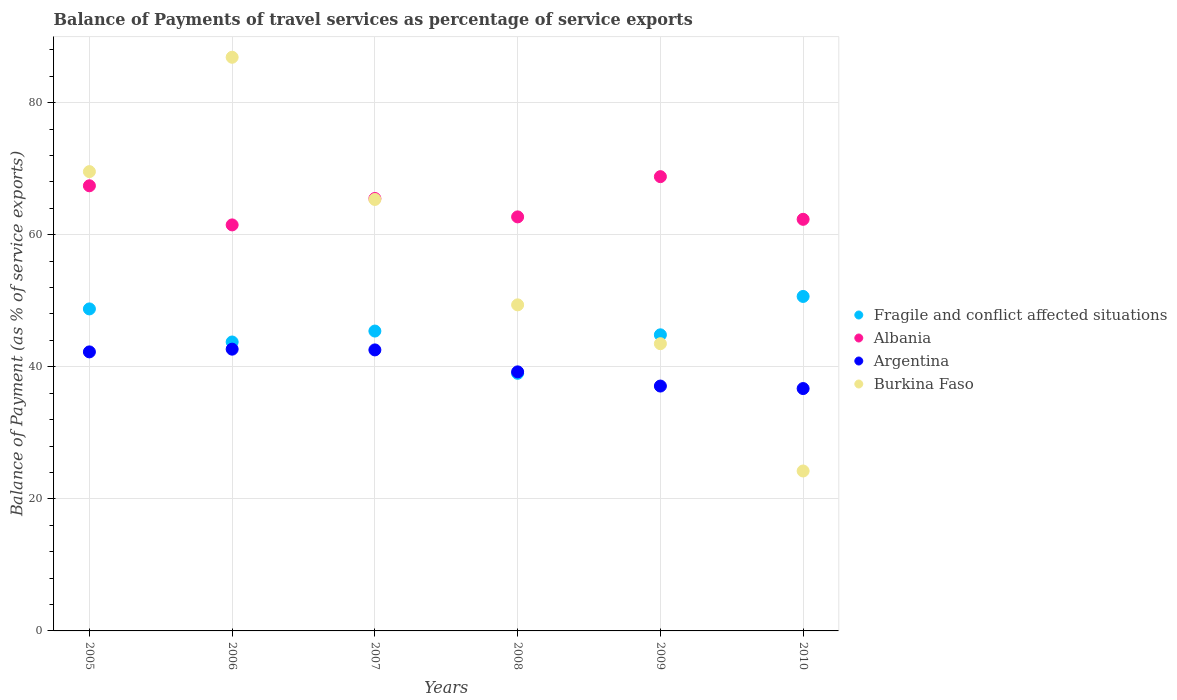How many different coloured dotlines are there?
Offer a very short reply. 4. Is the number of dotlines equal to the number of legend labels?
Your answer should be very brief. Yes. What is the balance of payments of travel services in Fragile and conflict affected situations in 2008?
Give a very brief answer. 39.02. Across all years, what is the maximum balance of payments of travel services in Fragile and conflict affected situations?
Keep it short and to the point. 50.66. Across all years, what is the minimum balance of payments of travel services in Burkina Faso?
Make the answer very short. 24.22. In which year was the balance of payments of travel services in Fragile and conflict affected situations maximum?
Your response must be concise. 2010. In which year was the balance of payments of travel services in Burkina Faso minimum?
Provide a succinct answer. 2010. What is the total balance of payments of travel services in Argentina in the graph?
Offer a very short reply. 240.51. What is the difference between the balance of payments of travel services in Burkina Faso in 2005 and that in 2008?
Offer a terse response. 20.18. What is the difference between the balance of payments of travel services in Argentina in 2005 and the balance of payments of travel services in Albania in 2010?
Offer a very short reply. -20.08. What is the average balance of payments of travel services in Fragile and conflict affected situations per year?
Give a very brief answer. 45.41. In the year 2007, what is the difference between the balance of payments of travel services in Albania and balance of payments of travel services in Fragile and conflict affected situations?
Your answer should be compact. 20.08. In how many years, is the balance of payments of travel services in Albania greater than 8 %?
Provide a succinct answer. 6. What is the ratio of the balance of payments of travel services in Fragile and conflict affected situations in 2007 to that in 2009?
Provide a succinct answer. 1.01. Is the balance of payments of travel services in Burkina Faso in 2007 less than that in 2008?
Give a very brief answer. No. Is the difference between the balance of payments of travel services in Albania in 2009 and 2010 greater than the difference between the balance of payments of travel services in Fragile and conflict affected situations in 2009 and 2010?
Offer a terse response. Yes. What is the difference between the highest and the second highest balance of payments of travel services in Fragile and conflict affected situations?
Provide a succinct answer. 1.89. What is the difference between the highest and the lowest balance of payments of travel services in Fragile and conflict affected situations?
Keep it short and to the point. 11.64. Is it the case that in every year, the sum of the balance of payments of travel services in Argentina and balance of payments of travel services in Burkina Faso  is greater than the sum of balance of payments of travel services in Fragile and conflict affected situations and balance of payments of travel services in Albania?
Provide a succinct answer. No. Does the balance of payments of travel services in Argentina monotonically increase over the years?
Your answer should be very brief. No. How many dotlines are there?
Make the answer very short. 4. Does the graph contain grids?
Offer a terse response. Yes. How many legend labels are there?
Give a very brief answer. 4. What is the title of the graph?
Keep it short and to the point. Balance of Payments of travel services as percentage of service exports. What is the label or title of the X-axis?
Give a very brief answer. Years. What is the label or title of the Y-axis?
Your answer should be very brief. Balance of Payment (as % of service exports). What is the Balance of Payment (as % of service exports) of Fragile and conflict affected situations in 2005?
Provide a succinct answer. 48.77. What is the Balance of Payment (as % of service exports) of Albania in 2005?
Offer a very short reply. 67.42. What is the Balance of Payment (as % of service exports) in Argentina in 2005?
Ensure brevity in your answer.  42.26. What is the Balance of Payment (as % of service exports) in Burkina Faso in 2005?
Your response must be concise. 69.56. What is the Balance of Payment (as % of service exports) of Fragile and conflict affected situations in 2006?
Offer a very short reply. 43.76. What is the Balance of Payment (as % of service exports) of Albania in 2006?
Provide a short and direct response. 61.49. What is the Balance of Payment (as % of service exports) in Argentina in 2006?
Make the answer very short. 42.67. What is the Balance of Payment (as % of service exports) of Burkina Faso in 2006?
Provide a succinct answer. 86.88. What is the Balance of Payment (as % of service exports) of Fragile and conflict affected situations in 2007?
Your answer should be very brief. 45.41. What is the Balance of Payment (as % of service exports) of Albania in 2007?
Offer a very short reply. 65.49. What is the Balance of Payment (as % of service exports) of Argentina in 2007?
Ensure brevity in your answer.  42.56. What is the Balance of Payment (as % of service exports) of Burkina Faso in 2007?
Your answer should be compact. 65.35. What is the Balance of Payment (as % of service exports) in Fragile and conflict affected situations in 2008?
Your response must be concise. 39.02. What is the Balance of Payment (as % of service exports) in Albania in 2008?
Make the answer very short. 62.7. What is the Balance of Payment (as % of service exports) in Argentina in 2008?
Offer a terse response. 39.23. What is the Balance of Payment (as % of service exports) of Burkina Faso in 2008?
Your answer should be compact. 49.38. What is the Balance of Payment (as % of service exports) of Fragile and conflict affected situations in 2009?
Keep it short and to the point. 44.84. What is the Balance of Payment (as % of service exports) of Albania in 2009?
Provide a succinct answer. 68.8. What is the Balance of Payment (as % of service exports) of Argentina in 2009?
Ensure brevity in your answer.  37.08. What is the Balance of Payment (as % of service exports) in Burkina Faso in 2009?
Provide a succinct answer. 43.5. What is the Balance of Payment (as % of service exports) in Fragile and conflict affected situations in 2010?
Your response must be concise. 50.66. What is the Balance of Payment (as % of service exports) of Albania in 2010?
Give a very brief answer. 62.34. What is the Balance of Payment (as % of service exports) in Argentina in 2010?
Ensure brevity in your answer.  36.71. What is the Balance of Payment (as % of service exports) of Burkina Faso in 2010?
Keep it short and to the point. 24.22. Across all years, what is the maximum Balance of Payment (as % of service exports) in Fragile and conflict affected situations?
Give a very brief answer. 50.66. Across all years, what is the maximum Balance of Payment (as % of service exports) in Albania?
Give a very brief answer. 68.8. Across all years, what is the maximum Balance of Payment (as % of service exports) in Argentina?
Your answer should be compact. 42.67. Across all years, what is the maximum Balance of Payment (as % of service exports) of Burkina Faso?
Your response must be concise. 86.88. Across all years, what is the minimum Balance of Payment (as % of service exports) in Fragile and conflict affected situations?
Your response must be concise. 39.02. Across all years, what is the minimum Balance of Payment (as % of service exports) of Albania?
Provide a short and direct response. 61.49. Across all years, what is the minimum Balance of Payment (as % of service exports) of Argentina?
Offer a terse response. 36.71. Across all years, what is the minimum Balance of Payment (as % of service exports) in Burkina Faso?
Offer a very short reply. 24.22. What is the total Balance of Payment (as % of service exports) in Fragile and conflict affected situations in the graph?
Provide a short and direct response. 272.46. What is the total Balance of Payment (as % of service exports) of Albania in the graph?
Your answer should be compact. 388.24. What is the total Balance of Payment (as % of service exports) in Argentina in the graph?
Give a very brief answer. 240.51. What is the total Balance of Payment (as % of service exports) in Burkina Faso in the graph?
Ensure brevity in your answer.  338.89. What is the difference between the Balance of Payment (as % of service exports) of Fragile and conflict affected situations in 2005 and that in 2006?
Your response must be concise. 5.01. What is the difference between the Balance of Payment (as % of service exports) in Albania in 2005 and that in 2006?
Your response must be concise. 5.92. What is the difference between the Balance of Payment (as % of service exports) in Argentina in 2005 and that in 2006?
Ensure brevity in your answer.  -0.41. What is the difference between the Balance of Payment (as % of service exports) of Burkina Faso in 2005 and that in 2006?
Provide a short and direct response. -17.32. What is the difference between the Balance of Payment (as % of service exports) of Fragile and conflict affected situations in 2005 and that in 2007?
Provide a succinct answer. 3.35. What is the difference between the Balance of Payment (as % of service exports) in Albania in 2005 and that in 2007?
Provide a succinct answer. 1.92. What is the difference between the Balance of Payment (as % of service exports) of Argentina in 2005 and that in 2007?
Your answer should be compact. -0.3. What is the difference between the Balance of Payment (as % of service exports) in Burkina Faso in 2005 and that in 2007?
Ensure brevity in your answer.  4.22. What is the difference between the Balance of Payment (as % of service exports) of Fragile and conflict affected situations in 2005 and that in 2008?
Your response must be concise. 9.75. What is the difference between the Balance of Payment (as % of service exports) in Albania in 2005 and that in 2008?
Provide a short and direct response. 4.71. What is the difference between the Balance of Payment (as % of service exports) of Argentina in 2005 and that in 2008?
Provide a succinct answer. 3.02. What is the difference between the Balance of Payment (as % of service exports) in Burkina Faso in 2005 and that in 2008?
Provide a succinct answer. 20.18. What is the difference between the Balance of Payment (as % of service exports) in Fragile and conflict affected situations in 2005 and that in 2009?
Provide a short and direct response. 3.92. What is the difference between the Balance of Payment (as % of service exports) in Albania in 2005 and that in 2009?
Provide a short and direct response. -1.38. What is the difference between the Balance of Payment (as % of service exports) in Argentina in 2005 and that in 2009?
Provide a short and direct response. 5.17. What is the difference between the Balance of Payment (as % of service exports) of Burkina Faso in 2005 and that in 2009?
Give a very brief answer. 26.06. What is the difference between the Balance of Payment (as % of service exports) in Fragile and conflict affected situations in 2005 and that in 2010?
Make the answer very short. -1.89. What is the difference between the Balance of Payment (as % of service exports) in Albania in 2005 and that in 2010?
Keep it short and to the point. 5.08. What is the difference between the Balance of Payment (as % of service exports) of Argentina in 2005 and that in 2010?
Provide a succinct answer. 5.55. What is the difference between the Balance of Payment (as % of service exports) of Burkina Faso in 2005 and that in 2010?
Ensure brevity in your answer.  45.34. What is the difference between the Balance of Payment (as % of service exports) of Fragile and conflict affected situations in 2006 and that in 2007?
Give a very brief answer. -1.66. What is the difference between the Balance of Payment (as % of service exports) in Albania in 2006 and that in 2007?
Ensure brevity in your answer.  -4. What is the difference between the Balance of Payment (as % of service exports) in Argentina in 2006 and that in 2007?
Offer a very short reply. 0.11. What is the difference between the Balance of Payment (as % of service exports) of Burkina Faso in 2006 and that in 2007?
Offer a terse response. 21.53. What is the difference between the Balance of Payment (as % of service exports) of Fragile and conflict affected situations in 2006 and that in 2008?
Make the answer very short. 4.74. What is the difference between the Balance of Payment (as % of service exports) of Albania in 2006 and that in 2008?
Give a very brief answer. -1.21. What is the difference between the Balance of Payment (as % of service exports) in Argentina in 2006 and that in 2008?
Provide a short and direct response. 3.44. What is the difference between the Balance of Payment (as % of service exports) in Burkina Faso in 2006 and that in 2008?
Your answer should be compact. 37.5. What is the difference between the Balance of Payment (as % of service exports) of Fragile and conflict affected situations in 2006 and that in 2009?
Your answer should be very brief. -1.09. What is the difference between the Balance of Payment (as % of service exports) of Albania in 2006 and that in 2009?
Make the answer very short. -7.31. What is the difference between the Balance of Payment (as % of service exports) in Argentina in 2006 and that in 2009?
Ensure brevity in your answer.  5.59. What is the difference between the Balance of Payment (as % of service exports) of Burkina Faso in 2006 and that in 2009?
Make the answer very short. 43.38. What is the difference between the Balance of Payment (as % of service exports) of Fragile and conflict affected situations in 2006 and that in 2010?
Offer a very short reply. -6.9. What is the difference between the Balance of Payment (as % of service exports) of Albania in 2006 and that in 2010?
Provide a short and direct response. -0.85. What is the difference between the Balance of Payment (as % of service exports) of Argentina in 2006 and that in 2010?
Offer a terse response. 5.97. What is the difference between the Balance of Payment (as % of service exports) of Burkina Faso in 2006 and that in 2010?
Provide a short and direct response. 62.66. What is the difference between the Balance of Payment (as % of service exports) of Fragile and conflict affected situations in 2007 and that in 2008?
Make the answer very short. 6.4. What is the difference between the Balance of Payment (as % of service exports) in Albania in 2007 and that in 2008?
Provide a short and direct response. 2.79. What is the difference between the Balance of Payment (as % of service exports) of Argentina in 2007 and that in 2008?
Your response must be concise. 3.32. What is the difference between the Balance of Payment (as % of service exports) of Burkina Faso in 2007 and that in 2008?
Give a very brief answer. 15.96. What is the difference between the Balance of Payment (as % of service exports) of Fragile and conflict affected situations in 2007 and that in 2009?
Your answer should be compact. 0.57. What is the difference between the Balance of Payment (as % of service exports) in Albania in 2007 and that in 2009?
Provide a succinct answer. -3.31. What is the difference between the Balance of Payment (as % of service exports) in Argentina in 2007 and that in 2009?
Offer a very short reply. 5.47. What is the difference between the Balance of Payment (as % of service exports) of Burkina Faso in 2007 and that in 2009?
Give a very brief answer. 21.85. What is the difference between the Balance of Payment (as % of service exports) in Fragile and conflict affected situations in 2007 and that in 2010?
Your answer should be compact. -5.24. What is the difference between the Balance of Payment (as % of service exports) in Albania in 2007 and that in 2010?
Make the answer very short. 3.16. What is the difference between the Balance of Payment (as % of service exports) in Argentina in 2007 and that in 2010?
Your response must be concise. 5.85. What is the difference between the Balance of Payment (as % of service exports) in Burkina Faso in 2007 and that in 2010?
Keep it short and to the point. 41.12. What is the difference between the Balance of Payment (as % of service exports) of Fragile and conflict affected situations in 2008 and that in 2009?
Provide a short and direct response. -5.83. What is the difference between the Balance of Payment (as % of service exports) in Albania in 2008 and that in 2009?
Provide a succinct answer. -6.09. What is the difference between the Balance of Payment (as % of service exports) in Argentina in 2008 and that in 2009?
Your answer should be compact. 2.15. What is the difference between the Balance of Payment (as % of service exports) in Burkina Faso in 2008 and that in 2009?
Make the answer very short. 5.88. What is the difference between the Balance of Payment (as % of service exports) of Fragile and conflict affected situations in 2008 and that in 2010?
Give a very brief answer. -11.64. What is the difference between the Balance of Payment (as % of service exports) of Albania in 2008 and that in 2010?
Ensure brevity in your answer.  0.37. What is the difference between the Balance of Payment (as % of service exports) of Argentina in 2008 and that in 2010?
Give a very brief answer. 2.53. What is the difference between the Balance of Payment (as % of service exports) in Burkina Faso in 2008 and that in 2010?
Ensure brevity in your answer.  25.16. What is the difference between the Balance of Payment (as % of service exports) of Fragile and conflict affected situations in 2009 and that in 2010?
Give a very brief answer. -5.81. What is the difference between the Balance of Payment (as % of service exports) in Albania in 2009 and that in 2010?
Give a very brief answer. 6.46. What is the difference between the Balance of Payment (as % of service exports) in Argentina in 2009 and that in 2010?
Ensure brevity in your answer.  0.38. What is the difference between the Balance of Payment (as % of service exports) in Burkina Faso in 2009 and that in 2010?
Provide a succinct answer. 19.28. What is the difference between the Balance of Payment (as % of service exports) in Fragile and conflict affected situations in 2005 and the Balance of Payment (as % of service exports) in Albania in 2006?
Your answer should be compact. -12.72. What is the difference between the Balance of Payment (as % of service exports) of Fragile and conflict affected situations in 2005 and the Balance of Payment (as % of service exports) of Argentina in 2006?
Ensure brevity in your answer.  6.1. What is the difference between the Balance of Payment (as % of service exports) of Fragile and conflict affected situations in 2005 and the Balance of Payment (as % of service exports) of Burkina Faso in 2006?
Your answer should be very brief. -38.11. What is the difference between the Balance of Payment (as % of service exports) in Albania in 2005 and the Balance of Payment (as % of service exports) in Argentina in 2006?
Keep it short and to the point. 24.74. What is the difference between the Balance of Payment (as % of service exports) of Albania in 2005 and the Balance of Payment (as % of service exports) of Burkina Faso in 2006?
Your response must be concise. -19.46. What is the difference between the Balance of Payment (as % of service exports) in Argentina in 2005 and the Balance of Payment (as % of service exports) in Burkina Faso in 2006?
Make the answer very short. -44.62. What is the difference between the Balance of Payment (as % of service exports) of Fragile and conflict affected situations in 2005 and the Balance of Payment (as % of service exports) of Albania in 2007?
Your answer should be very brief. -16.72. What is the difference between the Balance of Payment (as % of service exports) in Fragile and conflict affected situations in 2005 and the Balance of Payment (as % of service exports) in Argentina in 2007?
Provide a succinct answer. 6.21. What is the difference between the Balance of Payment (as % of service exports) in Fragile and conflict affected situations in 2005 and the Balance of Payment (as % of service exports) in Burkina Faso in 2007?
Your answer should be compact. -16.58. What is the difference between the Balance of Payment (as % of service exports) of Albania in 2005 and the Balance of Payment (as % of service exports) of Argentina in 2007?
Ensure brevity in your answer.  24.86. What is the difference between the Balance of Payment (as % of service exports) in Albania in 2005 and the Balance of Payment (as % of service exports) in Burkina Faso in 2007?
Your response must be concise. 2.07. What is the difference between the Balance of Payment (as % of service exports) of Argentina in 2005 and the Balance of Payment (as % of service exports) of Burkina Faso in 2007?
Your answer should be very brief. -23.09. What is the difference between the Balance of Payment (as % of service exports) of Fragile and conflict affected situations in 2005 and the Balance of Payment (as % of service exports) of Albania in 2008?
Make the answer very short. -13.94. What is the difference between the Balance of Payment (as % of service exports) in Fragile and conflict affected situations in 2005 and the Balance of Payment (as % of service exports) in Argentina in 2008?
Make the answer very short. 9.53. What is the difference between the Balance of Payment (as % of service exports) of Fragile and conflict affected situations in 2005 and the Balance of Payment (as % of service exports) of Burkina Faso in 2008?
Your answer should be compact. -0.61. What is the difference between the Balance of Payment (as % of service exports) of Albania in 2005 and the Balance of Payment (as % of service exports) of Argentina in 2008?
Make the answer very short. 28.18. What is the difference between the Balance of Payment (as % of service exports) in Albania in 2005 and the Balance of Payment (as % of service exports) in Burkina Faso in 2008?
Your response must be concise. 18.03. What is the difference between the Balance of Payment (as % of service exports) in Argentina in 2005 and the Balance of Payment (as % of service exports) in Burkina Faso in 2008?
Your answer should be compact. -7.12. What is the difference between the Balance of Payment (as % of service exports) in Fragile and conflict affected situations in 2005 and the Balance of Payment (as % of service exports) in Albania in 2009?
Make the answer very short. -20.03. What is the difference between the Balance of Payment (as % of service exports) of Fragile and conflict affected situations in 2005 and the Balance of Payment (as % of service exports) of Argentina in 2009?
Provide a short and direct response. 11.68. What is the difference between the Balance of Payment (as % of service exports) of Fragile and conflict affected situations in 2005 and the Balance of Payment (as % of service exports) of Burkina Faso in 2009?
Your answer should be very brief. 5.27. What is the difference between the Balance of Payment (as % of service exports) in Albania in 2005 and the Balance of Payment (as % of service exports) in Argentina in 2009?
Ensure brevity in your answer.  30.33. What is the difference between the Balance of Payment (as % of service exports) of Albania in 2005 and the Balance of Payment (as % of service exports) of Burkina Faso in 2009?
Keep it short and to the point. 23.92. What is the difference between the Balance of Payment (as % of service exports) in Argentina in 2005 and the Balance of Payment (as % of service exports) in Burkina Faso in 2009?
Give a very brief answer. -1.24. What is the difference between the Balance of Payment (as % of service exports) in Fragile and conflict affected situations in 2005 and the Balance of Payment (as % of service exports) in Albania in 2010?
Your response must be concise. -13.57. What is the difference between the Balance of Payment (as % of service exports) of Fragile and conflict affected situations in 2005 and the Balance of Payment (as % of service exports) of Argentina in 2010?
Make the answer very short. 12.06. What is the difference between the Balance of Payment (as % of service exports) in Fragile and conflict affected situations in 2005 and the Balance of Payment (as % of service exports) in Burkina Faso in 2010?
Your response must be concise. 24.55. What is the difference between the Balance of Payment (as % of service exports) in Albania in 2005 and the Balance of Payment (as % of service exports) in Argentina in 2010?
Make the answer very short. 30.71. What is the difference between the Balance of Payment (as % of service exports) of Albania in 2005 and the Balance of Payment (as % of service exports) of Burkina Faso in 2010?
Provide a short and direct response. 43.19. What is the difference between the Balance of Payment (as % of service exports) in Argentina in 2005 and the Balance of Payment (as % of service exports) in Burkina Faso in 2010?
Your response must be concise. 18.04. What is the difference between the Balance of Payment (as % of service exports) in Fragile and conflict affected situations in 2006 and the Balance of Payment (as % of service exports) in Albania in 2007?
Give a very brief answer. -21.73. What is the difference between the Balance of Payment (as % of service exports) of Fragile and conflict affected situations in 2006 and the Balance of Payment (as % of service exports) of Argentina in 2007?
Your response must be concise. 1.2. What is the difference between the Balance of Payment (as % of service exports) of Fragile and conflict affected situations in 2006 and the Balance of Payment (as % of service exports) of Burkina Faso in 2007?
Offer a terse response. -21.59. What is the difference between the Balance of Payment (as % of service exports) in Albania in 2006 and the Balance of Payment (as % of service exports) in Argentina in 2007?
Offer a terse response. 18.93. What is the difference between the Balance of Payment (as % of service exports) of Albania in 2006 and the Balance of Payment (as % of service exports) of Burkina Faso in 2007?
Offer a very short reply. -3.85. What is the difference between the Balance of Payment (as % of service exports) of Argentina in 2006 and the Balance of Payment (as % of service exports) of Burkina Faso in 2007?
Provide a succinct answer. -22.67. What is the difference between the Balance of Payment (as % of service exports) in Fragile and conflict affected situations in 2006 and the Balance of Payment (as % of service exports) in Albania in 2008?
Ensure brevity in your answer.  -18.95. What is the difference between the Balance of Payment (as % of service exports) in Fragile and conflict affected situations in 2006 and the Balance of Payment (as % of service exports) in Argentina in 2008?
Give a very brief answer. 4.52. What is the difference between the Balance of Payment (as % of service exports) of Fragile and conflict affected situations in 2006 and the Balance of Payment (as % of service exports) of Burkina Faso in 2008?
Keep it short and to the point. -5.62. What is the difference between the Balance of Payment (as % of service exports) in Albania in 2006 and the Balance of Payment (as % of service exports) in Argentina in 2008?
Keep it short and to the point. 22.26. What is the difference between the Balance of Payment (as % of service exports) of Albania in 2006 and the Balance of Payment (as % of service exports) of Burkina Faso in 2008?
Ensure brevity in your answer.  12.11. What is the difference between the Balance of Payment (as % of service exports) in Argentina in 2006 and the Balance of Payment (as % of service exports) in Burkina Faso in 2008?
Keep it short and to the point. -6.71. What is the difference between the Balance of Payment (as % of service exports) of Fragile and conflict affected situations in 2006 and the Balance of Payment (as % of service exports) of Albania in 2009?
Your answer should be compact. -25.04. What is the difference between the Balance of Payment (as % of service exports) in Fragile and conflict affected situations in 2006 and the Balance of Payment (as % of service exports) in Argentina in 2009?
Offer a very short reply. 6.67. What is the difference between the Balance of Payment (as % of service exports) of Fragile and conflict affected situations in 2006 and the Balance of Payment (as % of service exports) of Burkina Faso in 2009?
Offer a very short reply. 0.26. What is the difference between the Balance of Payment (as % of service exports) of Albania in 2006 and the Balance of Payment (as % of service exports) of Argentina in 2009?
Provide a short and direct response. 24.41. What is the difference between the Balance of Payment (as % of service exports) in Albania in 2006 and the Balance of Payment (as % of service exports) in Burkina Faso in 2009?
Your answer should be compact. 17.99. What is the difference between the Balance of Payment (as % of service exports) of Argentina in 2006 and the Balance of Payment (as % of service exports) of Burkina Faso in 2009?
Give a very brief answer. -0.83. What is the difference between the Balance of Payment (as % of service exports) in Fragile and conflict affected situations in 2006 and the Balance of Payment (as % of service exports) in Albania in 2010?
Provide a succinct answer. -18.58. What is the difference between the Balance of Payment (as % of service exports) of Fragile and conflict affected situations in 2006 and the Balance of Payment (as % of service exports) of Argentina in 2010?
Offer a terse response. 7.05. What is the difference between the Balance of Payment (as % of service exports) in Fragile and conflict affected situations in 2006 and the Balance of Payment (as % of service exports) in Burkina Faso in 2010?
Your answer should be very brief. 19.54. What is the difference between the Balance of Payment (as % of service exports) of Albania in 2006 and the Balance of Payment (as % of service exports) of Argentina in 2010?
Offer a very short reply. 24.78. What is the difference between the Balance of Payment (as % of service exports) of Albania in 2006 and the Balance of Payment (as % of service exports) of Burkina Faso in 2010?
Your answer should be very brief. 37.27. What is the difference between the Balance of Payment (as % of service exports) of Argentina in 2006 and the Balance of Payment (as % of service exports) of Burkina Faso in 2010?
Make the answer very short. 18.45. What is the difference between the Balance of Payment (as % of service exports) of Fragile and conflict affected situations in 2007 and the Balance of Payment (as % of service exports) of Albania in 2008?
Provide a succinct answer. -17.29. What is the difference between the Balance of Payment (as % of service exports) of Fragile and conflict affected situations in 2007 and the Balance of Payment (as % of service exports) of Argentina in 2008?
Your response must be concise. 6.18. What is the difference between the Balance of Payment (as % of service exports) in Fragile and conflict affected situations in 2007 and the Balance of Payment (as % of service exports) in Burkina Faso in 2008?
Provide a short and direct response. -3.97. What is the difference between the Balance of Payment (as % of service exports) in Albania in 2007 and the Balance of Payment (as % of service exports) in Argentina in 2008?
Give a very brief answer. 26.26. What is the difference between the Balance of Payment (as % of service exports) of Albania in 2007 and the Balance of Payment (as % of service exports) of Burkina Faso in 2008?
Give a very brief answer. 16.11. What is the difference between the Balance of Payment (as % of service exports) in Argentina in 2007 and the Balance of Payment (as % of service exports) in Burkina Faso in 2008?
Give a very brief answer. -6.82. What is the difference between the Balance of Payment (as % of service exports) of Fragile and conflict affected situations in 2007 and the Balance of Payment (as % of service exports) of Albania in 2009?
Your answer should be compact. -23.38. What is the difference between the Balance of Payment (as % of service exports) in Fragile and conflict affected situations in 2007 and the Balance of Payment (as % of service exports) in Argentina in 2009?
Offer a very short reply. 8.33. What is the difference between the Balance of Payment (as % of service exports) in Fragile and conflict affected situations in 2007 and the Balance of Payment (as % of service exports) in Burkina Faso in 2009?
Keep it short and to the point. 1.91. What is the difference between the Balance of Payment (as % of service exports) of Albania in 2007 and the Balance of Payment (as % of service exports) of Argentina in 2009?
Provide a short and direct response. 28.41. What is the difference between the Balance of Payment (as % of service exports) in Albania in 2007 and the Balance of Payment (as % of service exports) in Burkina Faso in 2009?
Your answer should be compact. 21.99. What is the difference between the Balance of Payment (as % of service exports) in Argentina in 2007 and the Balance of Payment (as % of service exports) in Burkina Faso in 2009?
Your answer should be very brief. -0.94. What is the difference between the Balance of Payment (as % of service exports) in Fragile and conflict affected situations in 2007 and the Balance of Payment (as % of service exports) in Albania in 2010?
Ensure brevity in your answer.  -16.92. What is the difference between the Balance of Payment (as % of service exports) in Fragile and conflict affected situations in 2007 and the Balance of Payment (as % of service exports) in Argentina in 2010?
Your answer should be very brief. 8.71. What is the difference between the Balance of Payment (as % of service exports) of Fragile and conflict affected situations in 2007 and the Balance of Payment (as % of service exports) of Burkina Faso in 2010?
Your answer should be very brief. 21.19. What is the difference between the Balance of Payment (as % of service exports) of Albania in 2007 and the Balance of Payment (as % of service exports) of Argentina in 2010?
Your answer should be compact. 28.79. What is the difference between the Balance of Payment (as % of service exports) in Albania in 2007 and the Balance of Payment (as % of service exports) in Burkina Faso in 2010?
Offer a terse response. 41.27. What is the difference between the Balance of Payment (as % of service exports) of Argentina in 2007 and the Balance of Payment (as % of service exports) of Burkina Faso in 2010?
Your answer should be very brief. 18.34. What is the difference between the Balance of Payment (as % of service exports) in Fragile and conflict affected situations in 2008 and the Balance of Payment (as % of service exports) in Albania in 2009?
Your response must be concise. -29.78. What is the difference between the Balance of Payment (as % of service exports) of Fragile and conflict affected situations in 2008 and the Balance of Payment (as % of service exports) of Argentina in 2009?
Provide a succinct answer. 1.93. What is the difference between the Balance of Payment (as % of service exports) of Fragile and conflict affected situations in 2008 and the Balance of Payment (as % of service exports) of Burkina Faso in 2009?
Provide a succinct answer. -4.48. What is the difference between the Balance of Payment (as % of service exports) in Albania in 2008 and the Balance of Payment (as % of service exports) in Argentina in 2009?
Your answer should be very brief. 25.62. What is the difference between the Balance of Payment (as % of service exports) in Albania in 2008 and the Balance of Payment (as % of service exports) in Burkina Faso in 2009?
Your response must be concise. 19.21. What is the difference between the Balance of Payment (as % of service exports) of Argentina in 2008 and the Balance of Payment (as % of service exports) of Burkina Faso in 2009?
Offer a very short reply. -4.27. What is the difference between the Balance of Payment (as % of service exports) in Fragile and conflict affected situations in 2008 and the Balance of Payment (as % of service exports) in Albania in 2010?
Your answer should be compact. -23.32. What is the difference between the Balance of Payment (as % of service exports) of Fragile and conflict affected situations in 2008 and the Balance of Payment (as % of service exports) of Argentina in 2010?
Give a very brief answer. 2.31. What is the difference between the Balance of Payment (as % of service exports) of Fragile and conflict affected situations in 2008 and the Balance of Payment (as % of service exports) of Burkina Faso in 2010?
Keep it short and to the point. 14.79. What is the difference between the Balance of Payment (as % of service exports) in Albania in 2008 and the Balance of Payment (as % of service exports) in Argentina in 2010?
Give a very brief answer. 26. What is the difference between the Balance of Payment (as % of service exports) of Albania in 2008 and the Balance of Payment (as % of service exports) of Burkina Faso in 2010?
Keep it short and to the point. 38.48. What is the difference between the Balance of Payment (as % of service exports) of Argentina in 2008 and the Balance of Payment (as % of service exports) of Burkina Faso in 2010?
Offer a very short reply. 15.01. What is the difference between the Balance of Payment (as % of service exports) of Fragile and conflict affected situations in 2009 and the Balance of Payment (as % of service exports) of Albania in 2010?
Your answer should be compact. -17.49. What is the difference between the Balance of Payment (as % of service exports) of Fragile and conflict affected situations in 2009 and the Balance of Payment (as % of service exports) of Argentina in 2010?
Provide a succinct answer. 8.14. What is the difference between the Balance of Payment (as % of service exports) of Fragile and conflict affected situations in 2009 and the Balance of Payment (as % of service exports) of Burkina Faso in 2010?
Make the answer very short. 20.62. What is the difference between the Balance of Payment (as % of service exports) in Albania in 2009 and the Balance of Payment (as % of service exports) in Argentina in 2010?
Keep it short and to the point. 32.09. What is the difference between the Balance of Payment (as % of service exports) of Albania in 2009 and the Balance of Payment (as % of service exports) of Burkina Faso in 2010?
Give a very brief answer. 44.58. What is the difference between the Balance of Payment (as % of service exports) of Argentina in 2009 and the Balance of Payment (as % of service exports) of Burkina Faso in 2010?
Provide a short and direct response. 12.86. What is the average Balance of Payment (as % of service exports) in Fragile and conflict affected situations per year?
Your response must be concise. 45.41. What is the average Balance of Payment (as % of service exports) in Albania per year?
Give a very brief answer. 64.71. What is the average Balance of Payment (as % of service exports) in Argentina per year?
Provide a short and direct response. 40.09. What is the average Balance of Payment (as % of service exports) in Burkina Faso per year?
Your answer should be compact. 56.48. In the year 2005, what is the difference between the Balance of Payment (as % of service exports) of Fragile and conflict affected situations and Balance of Payment (as % of service exports) of Albania?
Give a very brief answer. -18.65. In the year 2005, what is the difference between the Balance of Payment (as % of service exports) in Fragile and conflict affected situations and Balance of Payment (as % of service exports) in Argentina?
Give a very brief answer. 6.51. In the year 2005, what is the difference between the Balance of Payment (as % of service exports) in Fragile and conflict affected situations and Balance of Payment (as % of service exports) in Burkina Faso?
Your response must be concise. -20.79. In the year 2005, what is the difference between the Balance of Payment (as % of service exports) in Albania and Balance of Payment (as % of service exports) in Argentina?
Offer a terse response. 25.16. In the year 2005, what is the difference between the Balance of Payment (as % of service exports) in Albania and Balance of Payment (as % of service exports) in Burkina Faso?
Your answer should be compact. -2.15. In the year 2005, what is the difference between the Balance of Payment (as % of service exports) of Argentina and Balance of Payment (as % of service exports) of Burkina Faso?
Keep it short and to the point. -27.3. In the year 2006, what is the difference between the Balance of Payment (as % of service exports) in Fragile and conflict affected situations and Balance of Payment (as % of service exports) in Albania?
Offer a very short reply. -17.73. In the year 2006, what is the difference between the Balance of Payment (as % of service exports) of Fragile and conflict affected situations and Balance of Payment (as % of service exports) of Argentina?
Provide a succinct answer. 1.09. In the year 2006, what is the difference between the Balance of Payment (as % of service exports) of Fragile and conflict affected situations and Balance of Payment (as % of service exports) of Burkina Faso?
Ensure brevity in your answer.  -43.12. In the year 2006, what is the difference between the Balance of Payment (as % of service exports) of Albania and Balance of Payment (as % of service exports) of Argentina?
Ensure brevity in your answer.  18.82. In the year 2006, what is the difference between the Balance of Payment (as % of service exports) of Albania and Balance of Payment (as % of service exports) of Burkina Faso?
Provide a short and direct response. -25.39. In the year 2006, what is the difference between the Balance of Payment (as % of service exports) in Argentina and Balance of Payment (as % of service exports) in Burkina Faso?
Ensure brevity in your answer.  -44.21. In the year 2007, what is the difference between the Balance of Payment (as % of service exports) of Fragile and conflict affected situations and Balance of Payment (as % of service exports) of Albania?
Give a very brief answer. -20.08. In the year 2007, what is the difference between the Balance of Payment (as % of service exports) in Fragile and conflict affected situations and Balance of Payment (as % of service exports) in Argentina?
Make the answer very short. 2.86. In the year 2007, what is the difference between the Balance of Payment (as % of service exports) in Fragile and conflict affected situations and Balance of Payment (as % of service exports) in Burkina Faso?
Give a very brief answer. -19.93. In the year 2007, what is the difference between the Balance of Payment (as % of service exports) of Albania and Balance of Payment (as % of service exports) of Argentina?
Your response must be concise. 22.93. In the year 2007, what is the difference between the Balance of Payment (as % of service exports) in Albania and Balance of Payment (as % of service exports) in Burkina Faso?
Provide a short and direct response. 0.15. In the year 2007, what is the difference between the Balance of Payment (as % of service exports) of Argentina and Balance of Payment (as % of service exports) of Burkina Faso?
Keep it short and to the point. -22.79. In the year 2008, what is the difference between the Balance of Payment (as % of service exports) of Fragile and conflict affected situations and Balance of Payment (as % of service exports) of Albania?
Keep it short and to the point. -23.69. In the year 2008, what is the difference between the Balance of Payment (as % of service exports) in Fragile and conflict affected situations and Balance of Payment (as % of service exports) in Argentina?
Make the answer very short. -0.22. In the year 2008, what is the difference between the Balance of Payment (as % of service exports) of Fragile and conflict affected situations and Balance of Payment (as % of service exports) of Burkina Faso?
Offer a terse response. -10.37. In the year 2008, what is the difference between the Balance of Payment (as % of service exports) of Albania and Balance of Payment (as % of service exports) of Argentina?
Your answer should be compact. 23.47. In the year 2008, what is the difference between the Balance of Payment (as % of service exports) in Albania and Balance of Payment (as % of service exports) in Burkina Faso?
Offer a very short reply. 13.32. In the year 2008, what is the difference between the Balance of Payment (as % of service exports) in Argentina and Balance of Payment (as % of service exports) in Burkina Faso?
Your answer should be very brief. -10.15. In the year 2009, what is the difference between the Balance of Payment (as % of service exports) of Fragile and conflict affected situations and Balance of Payment (as % of service exports) of Albania?
Keep it short and to the point. -23.95. In the year 2009, what is the difference between the Balance of Payment (as % of service exports) in Fragile and conflict affected situations and Balance of Payment (as % of service exports) in Argentina?
Your answer should be very brief. 7.76. In the year 2009, what is the difference between the Balance of Payment (as % of service exports) of Fragile and conflict affected situations and Balance of Payment (as % of service exports) of Burkina Faso?
Give a very brief answer. 1.35. In the year 2009, what is the difference between the Balance of Payment (as % of service exports) in Albania and Balance of Payment (as % of service exports) in Argentina?
Keep it short and to the point. 31.71. In the year 2009, what is the difference between the Balance of Payment (as % of service exports) of Albania and Balance of Payment (as % of service exports) of Burkina Faso?
Your answer should be very brief. 25.3. In the year 2009, what is the difference between the Balance of Payment (as % of service exports) of Argentina and Balance of Payment (as % of service exports) of Burkina Faso?
Provide a succinct answer. -6.41. In the year 2010, what is the difference between the Balance of Payment (as % of service exports) of Fragile and conflict affected situations and Balance of Payment (as % of service exports) of Albania?
Your answer should be very brief. -11.68. In the year 2010, what is the difference between the Balance of Payment (as % of service exports) of Fragile and conflict affected situations and Balance of Payment (as % of service exports) of Argentina?
Your response must be concise. 13.95. In the year 2010, what is the difference between the Balance of Payment (as % of service exports) in Fragile and conflict affected situations and Balance of Payment (as % of service exports) in Burkina Faso?
Provide a succinct answer. 26.44. In the year 2010, what is the difference between the Balance of Payment (as % of service exports) in Albania and Balance of Payment (as % of service exports) in Argentina?
Your answer should be compact. 25.63. In the year 2010, what is the difference between the Balance of Payment (as % of service exports) in Albania and Balance of Payment (as % of service exports) in Burkina Faso?
Make the answer very short. 38.12. In the year 2010, what is the difference between the Balance of Payment (as % of service exports) in Argentina and Balance of Payment (as % of service exports) in Burkina Faso?
Offer a very short reply. 12.49. What is the ratio of the Balance of Payment (as % of service exports) of Fragile and conflict affected situations in 2005 to that in 2006?
Offer a terse response. 1.11. What is the ratio of the Balance of Payment (as % of service exports) in Albania in 2005 to that in 2006?
Offer a terse response. 1.1. What is the ratio of the Balance of Payment (as % of service exports) in Argentina in 2005 to that in 2006?
Offer a very short reply. 0.99. What is the ratio of the Balance of Payment (as % of service exports) of Burkina Faso in 2005 to that in 2006?
Offer a very short reply. 0.8. What is the ratio of the Balance of Payment (as % of service exports) in Fragile and conflict affected situations in 2005 to that in 2007?
Provide a succinct answer. 1.07. What is the ratio of the Balance of Payment (as % of service exports) in Albania in 2005 to that in 2007?
Ensure brevity in your answer.  1.03. What is the ratio of the Balance of Payment (as % of service exports) of Burkina Faso in 2005 to that in 2007?
Offer a very short reply. 1.06. What is the ratio of the Balance of Payment (as % of service exports) in Albania in 2005 to that in 2008?
Ensure brevity in your answer.  1.08. What is the ratio of the Balance of Payment (as % of service exports) in Argentina in 2005 to that in 2008?
Offer a terse response. 1.08. What is the ratio of the Balance of Payment (as % of service exports) of Burkina Faso in 2005 to that in 2008?
Your answer should be compact. 1.41. What is the ratio of the Balance of Payment (as % of service exports) of Fragile and conflict affected situations in 2005 to that in 2009?
Your response must be concise. 1.09. What is the ratio of the Balance of Payment (as % of service exports) of Albania in 2005 to that in 2009?
Offer a very short reply. 0.98. What is the ratio of the Balance of Payment (as % of service exports) of Argentina in 2005 to that in 2009?
Make the answer very short. 1.14. What is the ratio of the Balance of Payment (as % of service exports) in Burkina Faso in 2005 to that in 2009?
Offer a terse response. 1.6. What is the ratio of the Balance of Payment (as % of service exports) in Fragile and conflict affected situations in 2005 to that in 2010?
Keep it short and to the point. 0.96. What is the ratio of the Balance of Payment (as % of service exports) in Albania in 2005 to that in 2010?
Provide a succinct answer. 1.08. What is the ratio of the Balance of Payment (as % of service exports) of Argentina in 2005 to that in 2010?
Give a very brief answer. 1.15. What is the ratio of the Balance of Payment (as % of service exports) in Burkina Faso in 2005 to that in 2010?
Offer a very short reply. 2.87. What is the ratio of the Balance of Payment (as % of service exports) in Fragile and conflict affected situations in 2006 to that in 2007?
Offer a very short reply. 0.96. What is the ratio of the Balance of Payment (as % of service exports) in Albania in 2006 to that in 2007?
Offer a terse response. 0.94. What is the ratio of the Balance of Payment (as % of service exports) of Argentina in 2006 to that in 2007?
Provide a succinct answer. 1. What is the ratio of the Balance of Payment (as % of service exports) in Burkina Faso in 2006 to that in 2007?
Your response must be concise. 1.33. What is the ratio of the Balance of Payment (as % of service exports) of Fragile and conflict affected situations in 2006 to that in 2008?
Make the answer very short. 1.12. What is the ratio of the Balance of Payment (as % of service exports) in Albania in 2006 to that in 2008?
Make the answer very short. 0.98. What is the ratio of the Balance of Payment (as % of service exports) of Argentina in 2006 to that in 2008?
Keep it short and to the point. 1.09. What is the ratio of the Balance of Payment (as % of service exports) in Burkina Faso in 2006 to that in 2008?
Your answer should be compact. 1.76. What is the ratio of the Balance of Payment (as % of service exports) in Fragile and conflict affected situations in 2006 to that in 2009?
Offer a terse response. 0.98. What is the ratio of the Balance of Payment (as % of service exports) in Albania in 2006 to that in 2009?
Your answer should be very brief. 0.89. What is the ratio of the Balance of Payment (as % of service exports) of Argentina in 2006 to that in 2009?
Keep it short and to the point. 1.15. What is the ratio of the Balance of Payment (as % of service exports) of Burkina Faso in 2006 to that in 2009?
Ensure brevity in your answer.  2. What is the ratio of the Balance of Payment (as % of service exports) of Fragile and conflict affected situations in 2006 to that in 2010?
Your answer should be very brief. 0.86. What is the ratio of the Balance of Payment (as % of service exports) of Albania in 2006 to that in 2010?
Your answer should be very brief. 0.99. What is the ratio of the Balance of Payment (as % of service exports) of Argentina in 2006 to that in 2010?
Your answer should be very brief. 1.16. What is the ratio of the Balance of Payment (as % of service exports) in Burkina Faso in 2006 to that in 2010?
Provide a succinct answer. 3.59. What is the ratio of the Balance of Payment (as % of service exports) of Fragile and conflict affected situations in 2007 to that in 2008?
Offer a terse response. 1.16. What is the ratio of the Balance of Payment (as % of service exports) in Albania in 2007 to that in 2008?
Provide a short and direct response. 1.04. What is the ratio of the Balance of Payment (as % of service exports) in Argentina in 2007 to that in 2008?
Offer a very short reply. 1.08. What is the ratio of the Balance of Payment (as % of service exports) of Burkina Faso in 2007 to that in 2008?
Ensure brevity in your answer.  1.32. What is the ratio of the Balance of Payment (as % of service exports) in Fragile and conflict affected situations in 2007 to that in 2009?
Your answer should be compact. 1.01. What is the ratio of the Balance of Payment (as % of service exports) of Albania in 2007 to that in 2009?
Your response must be concise. 0.95. What is the ratio of the Balance of Payment (as % of service exports) of Argentina in 2007 to that in 2009?
Ensure brevity in your answer.  1.15. What is the ratio of the Balance of Payment (as % of service exports) in Burkina Faso in 2007 to that in 2009?
Offer a very short reply. 1.5. What is the ratio of the Balance of Payment (as % of service exports) in Fragile and conflict affected situations in 2007 to that in 2010?
Your response must be concise. 0.9. What is the ratio of the Balance of Payment (as % of service exports) in Albania in 2007 to that in 2010?
Offer a very short reply. 1.05. What is the ratio of the Balance of Payment (as % of service exports) in Argentina in 2007 to that in 2010?
Provide a short and direct response. 1.16. What is the ratio of the Balance of Payment (as % of service exports) of Burkina Faso in 2007 to that in 2010?
Provide a succinct answer. 2.7. What is the ratio of the Balance of Payment (as % of service exports) in Fragile and conflict affected situations in 2008 to that in 2009?
Keep it short and to the point. 0.87. What is the ratio of the Balance of Payment (as % of service exports) of Albania in 2008 to that in 2009?
Ensure brevity in your answer.  0.91. What is the ratio of the Balance of Payment (as % of service exports) in Argentina in 2008 to that in 2009?
Ensure brevity in your answer.  1.06. What is the ratio of the Balance of Payment (as % of service exports) of Burkina Faso in 2008 to that in 2009?
Provide a succinct answer. 1.14. What is the ratio of the Balance of Payment (as % of service exports) of Fragile and conflict affected situations in 2008 to that in 2010?
Offer a terse response. 0.77. What is the ratio of the Balance of Payment (as % of service exports) in Albania in 2008 to that in 2010?
Your answer should be very brief. 1.01. What is the ratio of the Balance of Payment (as % of service exports) of Argentina in 2008 to that in 2010?
Ensure brevity in your answer.  1.07. What is the ratio of the Balance of Payment (as % of service exports) of Burkina Faso in 2008 to that in 2010?
Offer a terse response. 2.04. What is the ratio of the Balance of Payment (as % of service exports) in Fragile and conflict affected situations in 2009 to that in 2010?
Offer a very short reply. 0.89. What is the ratio of the Balance of Payment (as % of service exports) in Albania in 2009 to that in 2010?
Provide a short and direct response. 1.1. What is the ratio of the Balance of Payment (as % of service exports) in Argentina in 2009 to that in 2010?
Offer a terse response. 1.01. What is the ratio of the Balance of Payment (as % of service exports) of Burkina Faso in 2009 to that in 2010?
Offer a very short reply. 1.8. What is the difference between the highest and the second highest Balance of Payment (as % of service exports) in Fragile and conflict affected situations?
Offer a terse response. 1.89. What is the difference between the highest and the second highest Balance of Payment (as % of service exports) of Albania?
Keep it short and to the point. 1.38. What is the difference between the highest and the second highest Balance of Payment (as % of service exports) of Argentina?
Give a very brief answer. 0.11. What is the difference between the highest and the second highest Balance of Payment (as % of service exports) in Burkina Faso?
Your response must be concise. 17.32. What is the difference between the highest and the lowest Balance of Payment (as % of service exports) in Fragile and conflict affected situations?
Make the answer very short. 11.64. What is the difference between the highest and the lowest Balance of Payment (as % of service exports) of Albania?
Make the answer very short. 7.31. What is the difference between the highest and the lowest Balance of Payment (as % of service exports) in Argentina?
Offer a terse response. 5.97. What is the difference between the highest and the lowest Balance of Payment (as % of service exports) in Burkina Faso?
Provide a short and direct response. 62.66. 